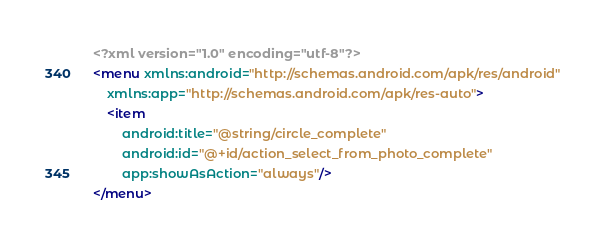Convert code to text. <code><loc_0><loc_0><loc_500><loc_500><_XML_><?xml version="1.0" encoding="utf-8"?>
<menu xmlns:android="http://schemas.android.com/apk/res/android"
    xmlns:app="http://schemas.android.com/apk/res-auto">
    <item
        android:title="@string/circle_complete"
        android:id="@+id/action_select_from_photo_complete"
        app:showAsAction="always"/>
</menu></code> 